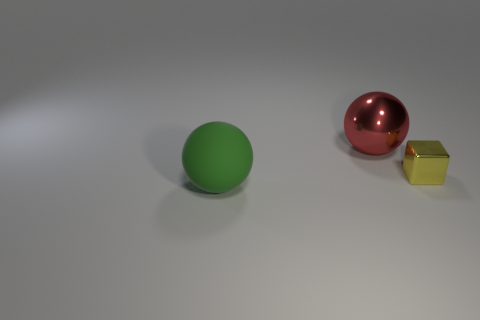Are there any other things that have the same size as the yellow metal block?
Your response must be concise. No. Are there any other things that are the same shape as the yellow thing?
Offer a very short reply. No. Is the number of matte objects that are behind the large green rubber thing the same as the number of small red matte objects?
Give a very brief answer. Yes. There is a thing that is to the left of the big shiny sphere; is its shape the same as the red shiny thing?
Offer a very short reply. Yes. There is a tiny metal thing; what shape is it?
Keep it short and to the point. Cube. The sphere left of the shiny object on the left side of the metallic object to the right of the big metal sphere is made of what material?
Provide a succinct answer. Rubber. How many objects are either large matte objects or metal spheres?
Provide a short and direct response. 2. Does the big ball that is behind the green sphere have the same material as the yellow object?
Your response must be concise. Yes. What number of objects are big balls behind the big green rubber thing or gray rubber cylinders?
Give a very brief answer. 1. There is another object that is the same material as the big red thing; what color is it?
Your response must be concise. Yellow. 